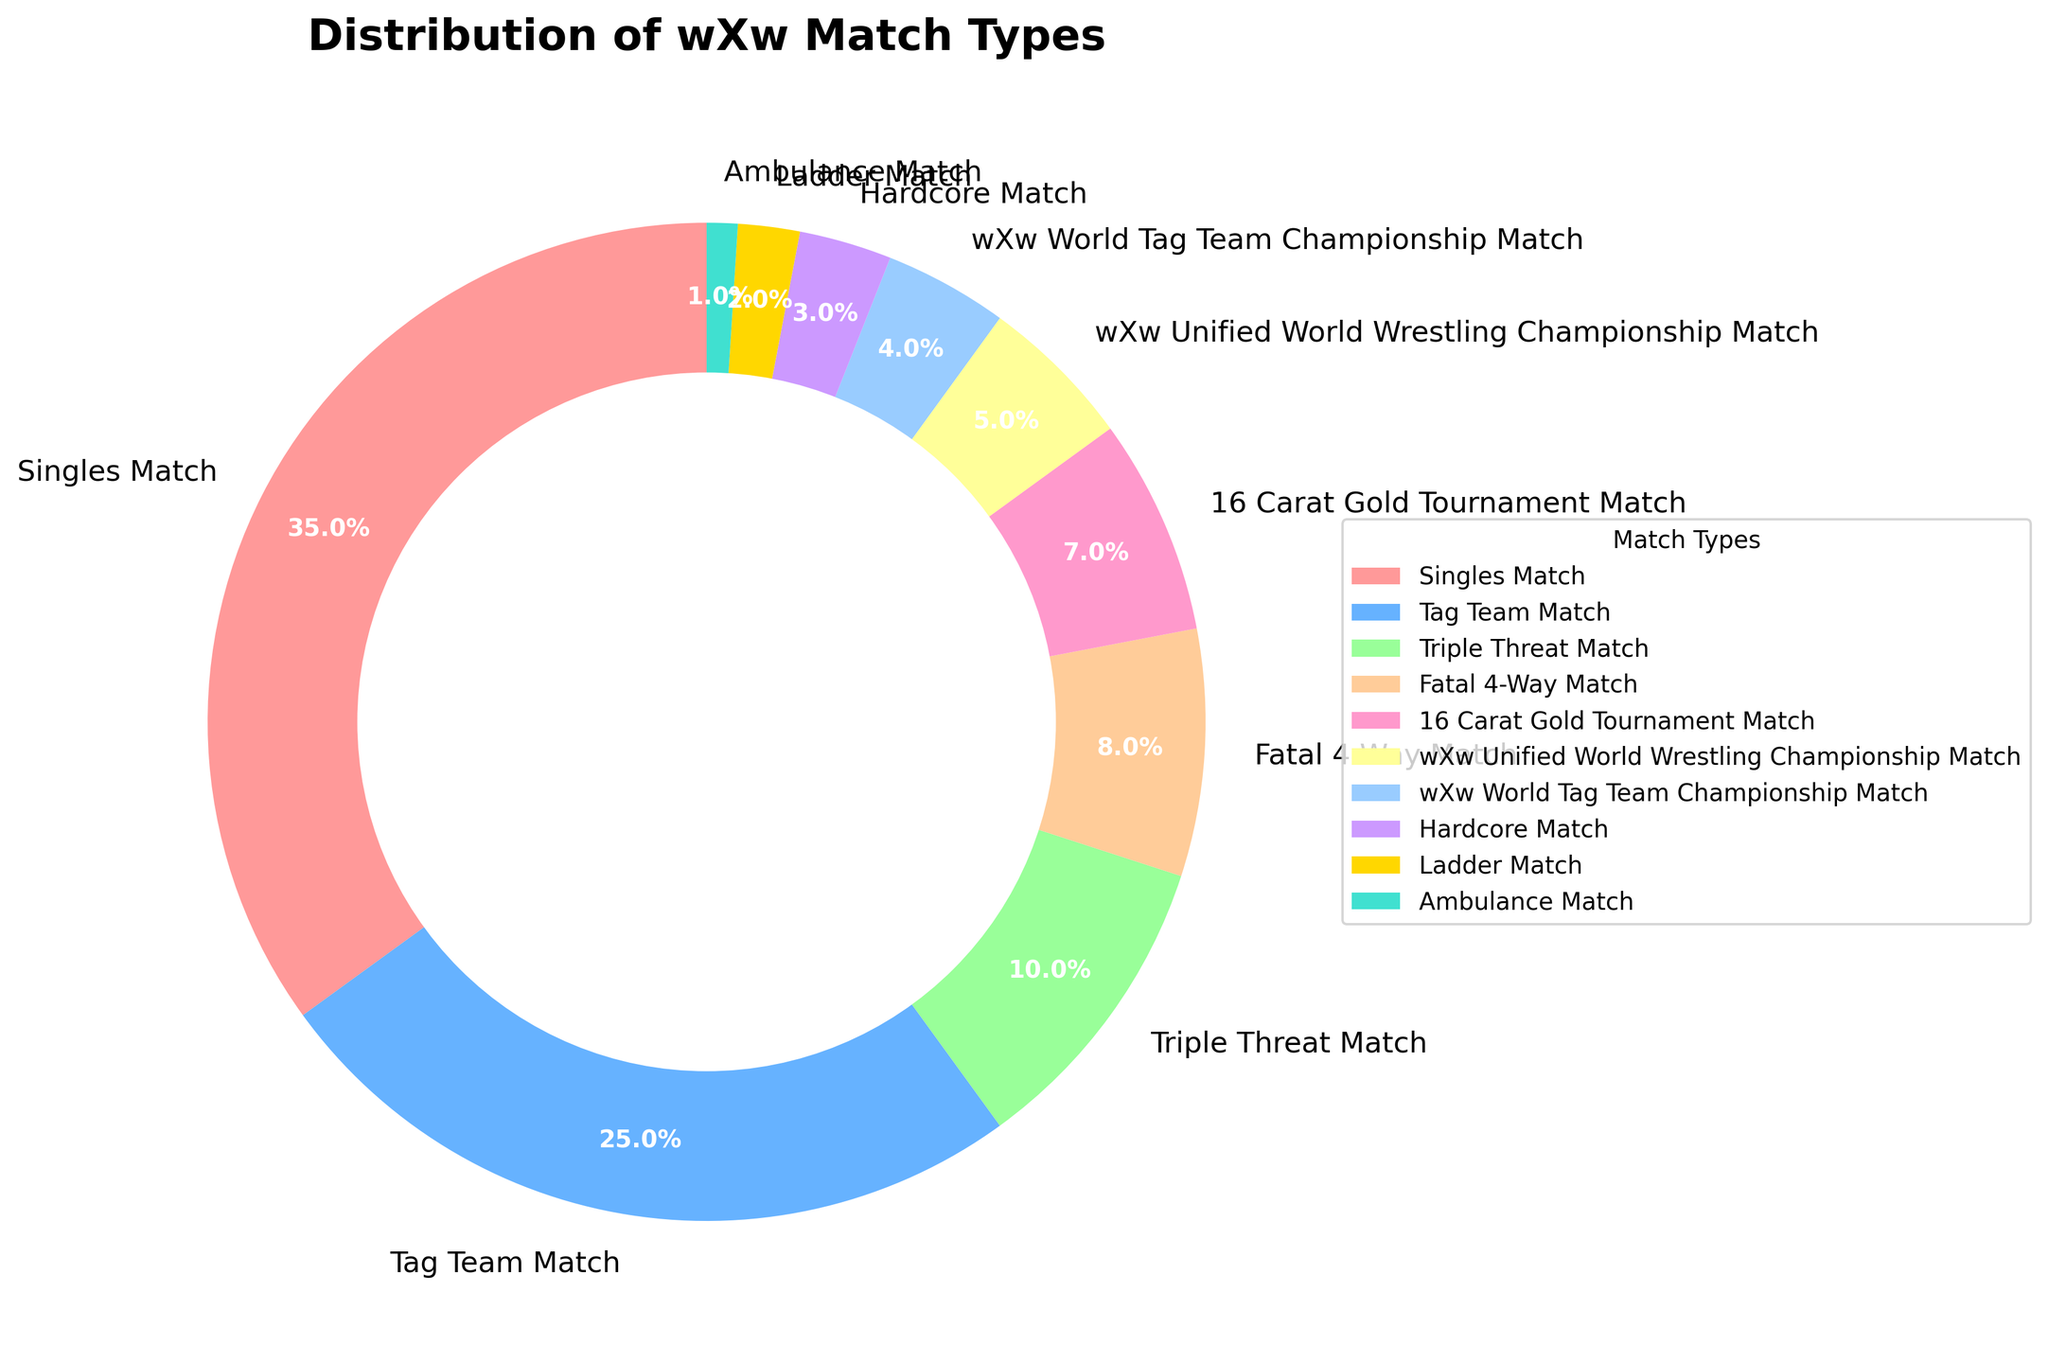What percentage of matches were either Tag Team Matches or Singles Matches? Tag Team Matches are 25% and Singles Matches are 35%. Adding them together gives 25% + 35% = 60%.
Answer: 60% Which match type has the smallest percentage? By looking at the percentages, the Ambulance Match has the smallest percentage of 1%.
Answer: Ambulance Match How many match types have a percentage greater than 20%? Singles Matches are 35% and Tag Team Matches are 25%. Both are greater than 20%, making a total of two match types.
Answer: 2 How does the percentage of Triple Threat Matches compare to that of Fatal 4-Way Matches? Triple Threat Matches are at 10% and Fatal 4-Way Matches are at 8%. Therefore, Triple Threat Matches have a higher percentage.
Answer: Triple Threat Matches have a higher percentage Are there more Hardcore Matches or Ladder Matches? Hardcore Matches are at 3% while Ladder Matches are at 2%. Hence, there are more Hardcore Matches.
Answer: Hardcore Matches Which match type is the second most common? Singles Matches are the most common at 35%, so the second most common is Tag Team Matches at 25%.
Answer: Tag Team Matches What is the combined percentage of all the matches that are not title matches (Unified World Wrestling or World Tag Team Championship)? The title matches make up 5% + 4% = 9%. So, the percentage of all other matches is 100% - 9% = 91%.
Answer: 91% What is the total percentage of matches that are part of specific tournaments or specialty matches (16 Carat Gold Tournament, Hardcore Match, Ladder Match, Ambulance Match)? Summing up their percentages: 7% (16 Carat Gold) + 3% (Hardcore) + 2% (Ladder) + 1% (Ambulance) = 13%.
Answer: 13% If you combine the three least common match types, what percentage do they represent? The least common match types are Ladder Match (2%), Ambulance Match (1%), and wXw World Tag Team Championship Match (4%). Adding them together: 2% + 1% + 4% = 7%.
Answer: 7% What color represents Fatal 4-Way Matches in the pie chart? Fatal 4-Way Matches are depicted in a distinct section of the pie chart and their color is pink.
Answer: pink 